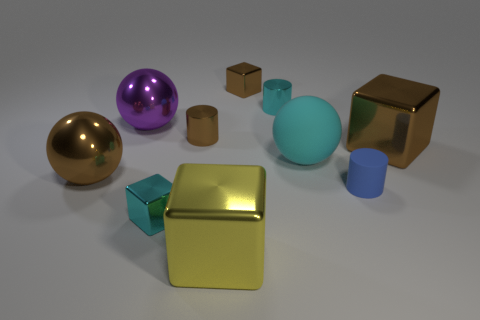Do the small matte cylinder and the matte sphere have the same color?
Keep it short and to the point. No. There is a small object that is to the left of the yellow cube and in front of the big brown metal ball; what is its material?
Give a very brief answer. Metal. What size is the cyan cylinder?
Offer a terse response. Small. What number of small blocks are behind the brown object to the left of the tiny cyan thing that is in front of the big cyan ball?
Provide a short and direct response. 1. What shape is the tiny cyan metallic object to the right of the tiny cyan thing that is in front of the big purple ball?
Your response must be concise. Cylinder. The other brown thing that is the same shape as the big matte thing is what size?
Make the answer very short. Large. Is there anything else that is the same size as the yellow metallic thing?
Make the answer very short. Yes. What color is the small metallic cube on the right side of the tiny cyan metal cube?
Give a very brief answer. Brown. What is the material of the big cube that is left of the tiny metallic cube that is on the right side of the cyan cube that is in front of the big brown metal cube?
Your answer should be very brief. Metal. What is the size of the cube on the right side of the tiny metallic block behind the small blue rubber object?
Your answer should be compact. Large. 